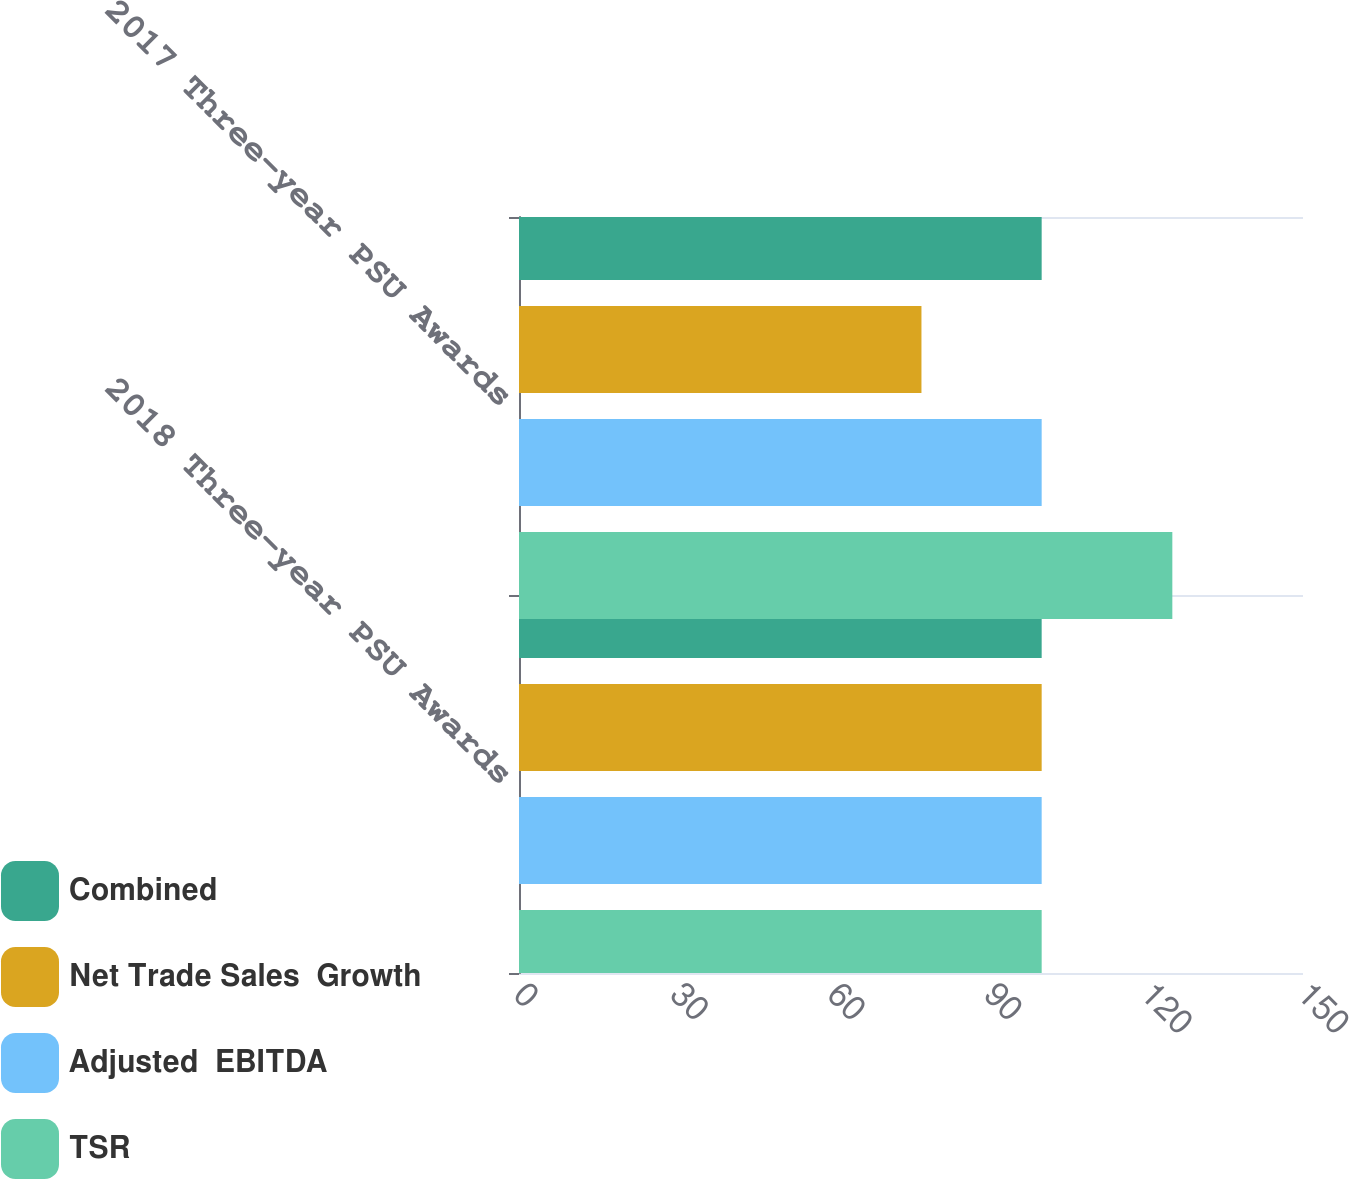<chart> <loc_0><loc_0><loc_500><loc_500><stacked_bar_chart><ecel><fcel>2018 Three-year PSU Awards<fcel>2017 Three-year PSU Awards<nl><fcel>Combined<fcel>100<fcel>100<nl><fcel>Net Trade Sales  Growth<fcel>100<fcel>77<nl><fcel>Adjusted  EBITDA<fcel>100<fcel>100<nl><fcel>TSR<fcel>100<fcel>125<nl></chart> 